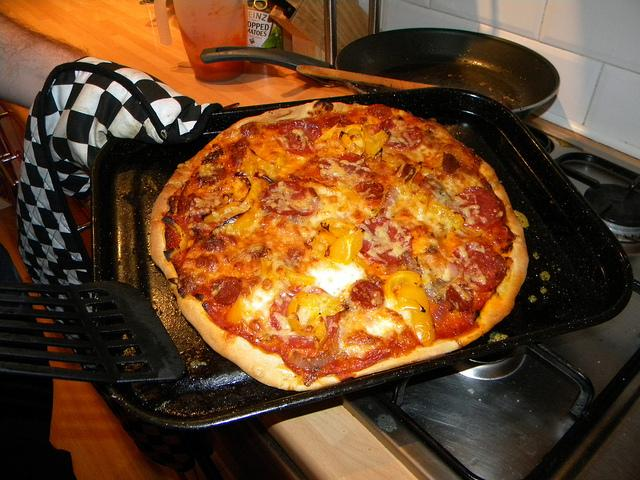The pizza came out of the oven powered by which fuel source? gas 